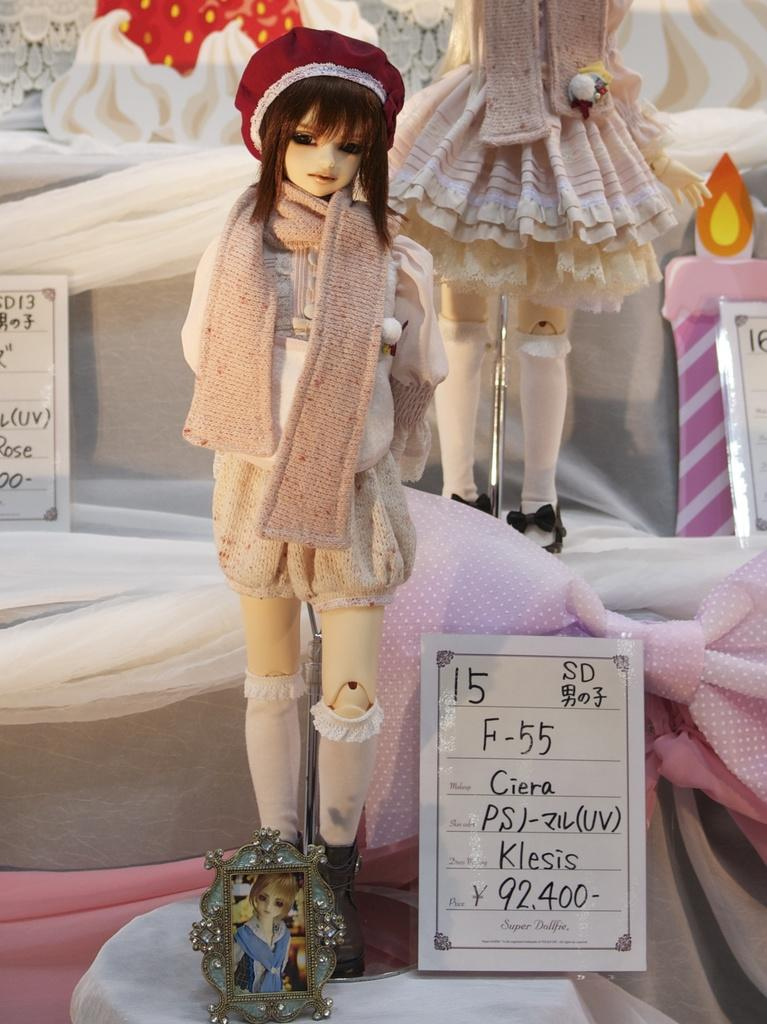What type of dolls are in the image? There are Barbie dolls in the image. What information is provided about the dolls in the image? There are price cards in the image, which suggests that the dolls are for sale. What can be seen in the background of the image? There appears to be a poster in the background of the image. What type of bottle is being used to create motion in the image? There is no bottle present in the image, and therefore no motion is being created by a bottle. 